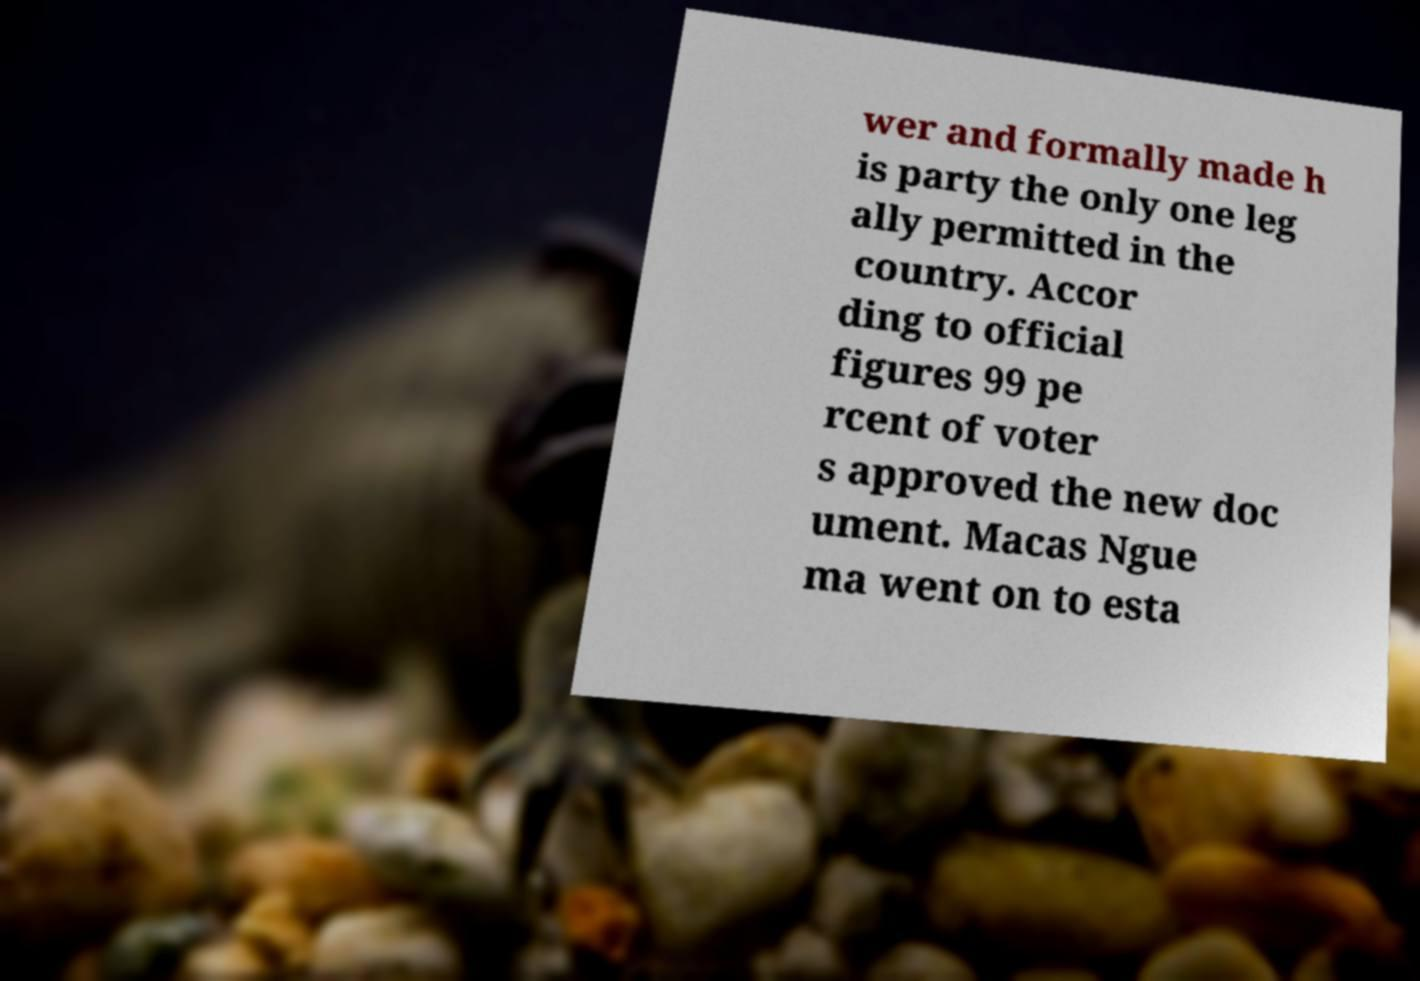I need the written content from this picture converted into text. Can you do that? wer and formally made h is party the only one leg ally permitted in the country. Accor ding to official figures 99 pe rcent of voter s approved the new doc ument. Macas Ngue ma went on to esta 